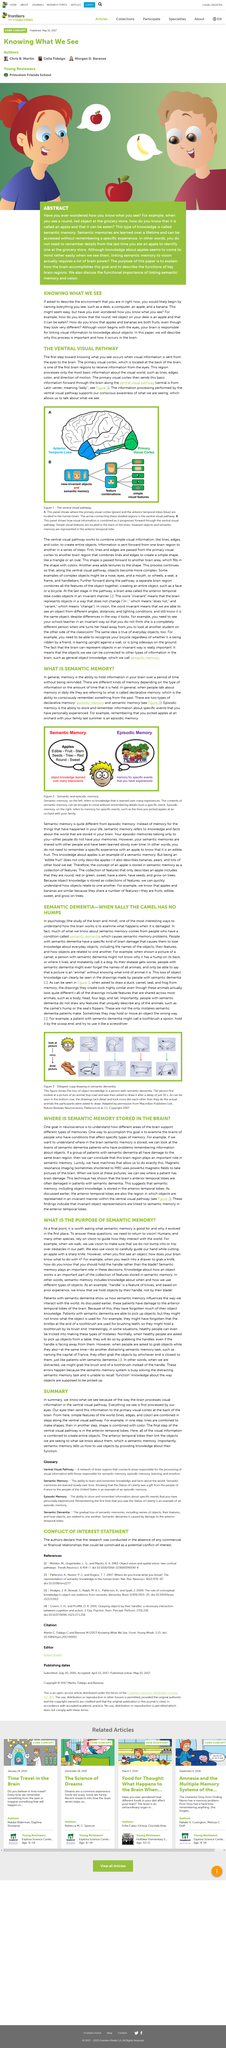Highlight a few significant elements in this photo. Memory is the ability to retain information in the brain for an extended period of time without constant reminders. The primary visual cortex is located at the back of the brain. Yes, there are different types of memory, depending on the type of information or the duration of its retention. Semantic dementia is caused by damage to the brain. When a person with semantic dementia is asked to draw an animal they have seen drawn just 10 seconds ago, they are likely to produce a generic-looking animal that lacks important details and is unfamiliar in appearance. 